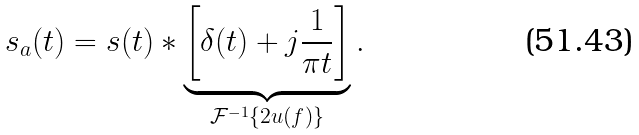Convert formula to latex. <formula><loc_0><loc_0><loc_500><loc_500>s _ { a } ( t ) = s ( t ) * \underbrace { \left [ \delta ( t ) + j { \frac { 1 } { \pi t } } \right ] } _ { { \mathcal { F } } ^ { - 1 } \{ 2 u ( f ) \} } .</formula> 